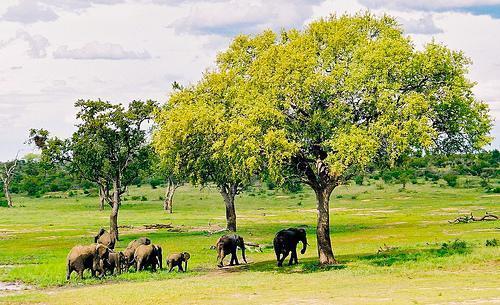How many elephants are in this photo?
Give a very brief answer. 9. 